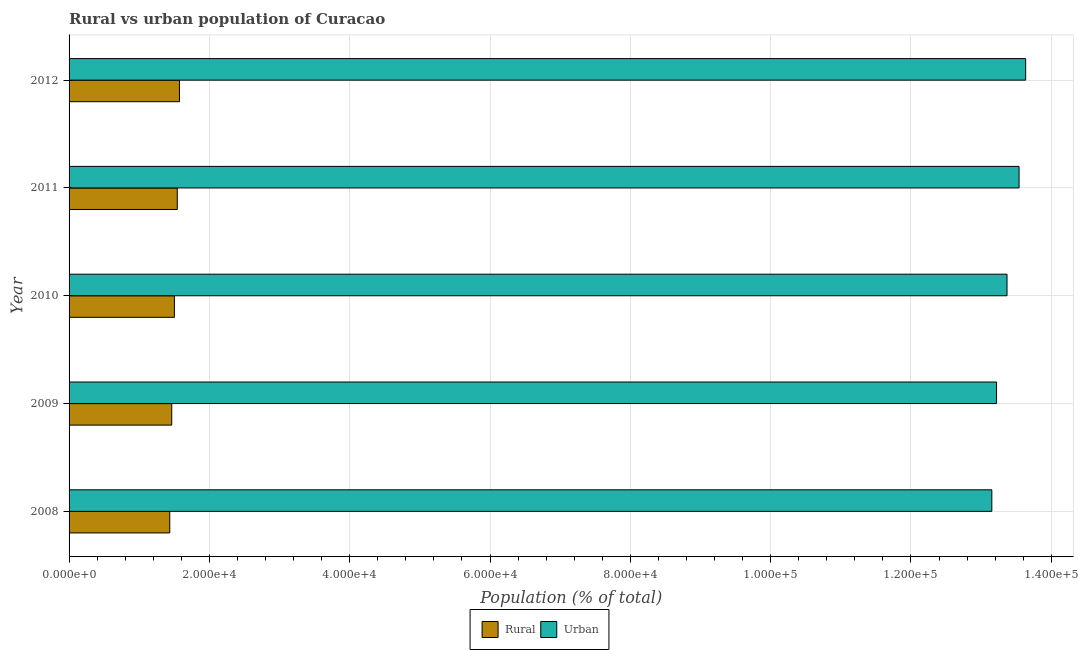How many different coloured bars are there?
Offer a terse response. 2. How many groups of bars are there?
Make the answer very short. 5. Are the number of bars per tick equal to the number of legend labels?
Provide a short and direct response. Yes. How many bars are there on the 3rd tick from the bottom?
Your response must be concise. 2. What is the label of the 5th group of bars from the top?
Provide a succinct answer. 2008. What is the urban population density in 2011?
Provide a succinct answer. 1.35e+05. Across all years, what is the maximum urban population density?
Keep it short and to the point. 1.36e+05. Across all years, what is the minimum urban population density?
Provide a short and direct response. 1.32e+05. In which year was the rural population density maximum?
Provide a short and direct response. 2012. In which year was the urban population density minimum?
Keep it short and to the point. 2008. What is the total rural population density in the graph?
Offer a terse response. 7.52e+04. What is the difference between the urban population density in 2009 and that in 2011?
Provide a short and direct response. -3209. What is the difference between the rural population density in 2008 and the urban population density in 2012?
Your answer should be compact. -1.22e+05. What is the average urban population density per year?
Your answer should be compact. 1.34e+05. In the year 2008, what is the difference between the rural population density and urban population density?
Provide a short and direct response. -1.17e+05. In how many years, is the rural population density greater than 124000 %?
Provide a succinct answer. 0. What is the ratio of the rural population density in 2009 to that in 2010?
Your answer should be compact. 0.97. Is the difference between the urban population density in 2011 and 2012 greater than the difference between the rural population density in 2011 and 2012?
Ensure brevity in your answer.  No. What is the difference between the highest and the second highest rural population density?
Provide a short and direct response. 316. What is the difference between the highest and the lowest rural population density?
Your answer should be compact. 1385. What does the 2nd bar from the top in 2008 represents?
Ensure brevity in your answer.  Rural. What does the 1st bar from the bottom in 2011 represents?
Your answer should be very brief. Rural. How many years are there in the graph?
Offer a terse response. 5. Does the graph contain any zero values?
Offer a terse response. No. Does the graph contain grids?
Offer a very short reply. Yes. How many legend labels are there?
Provide a short and direct response. 2. What is the title of the graph?
Your answer should be compact. Rural vs urban population of Curacao. What is the label or title of the X-axis?
Make the answer very short. Population (% of total). What is the label or title of the Y-axis?
Offer a very short reply. Year. What is the Population (% of total) in Rural in 2008?
Your answer should be very brief. 1.44e+04. What is the Population (% of total) of Urban in 2008?
Provide a succinct answer. 1.32e+05. What is the Population (% of total) in Rural in 2009?
Offer a very short reply. 1.46e+04. What is the Population (% of total) in Urban in 2009?
Ensure brevity in your answer.  1.32e+05. What is the Population (% of total) in Rural in 2010?
Offer a very short reply. 1.50e+04. What is the Population (% of total) of Urban in 2010?
Your answer should be very brief. 1.34e+05. What is the Population (% of total) in Rural in 2011?
Make the answer very short. 1.54e+04. What is the Population (% of total) of Urban in 2011?
Ensure brevity in your answer.  1.35e+05. What is the Population (% of total) in Rural in 2012?
Give a very brief answer. 1.57e+04. What is the Population (% of total) in Urban in 2012?
Your response must be concise. 1.36e+05. Across all years, what is the maximum Population (% of total) of Rural?
Make the answer very short. 1.57e+04. Across all years, what is the maximum Population (% of total) in Urban?
Make the answer very short. 1.36e+05. Across all years, what is the minimum Population (% of total) of Rural?
Your answer should be very brief. 1.44e+04. Across all years, what is the minimum Population (% of total) in Urban?
Your answer should be compact. 1.32e+05. What is the total Population (% of total) in Rural in the graph?
Offer a terse response. 7.52e+04. What is the total Population (% of total) of Urban in the graph?
Provide a succinct answer. 6.69e+05. What is the difference between the Population (% of total) of Rural in 2008 and that in 2009?
Your answer should be compact. -280. What is the difference between the Population (% of total) of Urban in 2008 and that in 2009?
Keep it short and to the point. -673. What is the difference between the Population (% of total) in Rural in 2008 and that in 2010?
Your response must be concise. -659. What is the difference between the Population (% of total) of Urban in 2008 and that in 2010?
Provide a short and direct response. -2164. What is the difference between the Population (% of total) in Rural in 2008 and that in 2011?
Your response must be concise. -1069. What is the difference between the Population (% of total) of Urban in 2008 and that in 2011?
Give a very brief answer. -3882. What is the difference between the Population (% of total) of Rural in 2008 and that in 2012?
Ensure brevity in your answer.  -1385. What is the difference between the Population (% of total) in Urban in 2008 and that in 2012?
Your answer should be very brief. -4823. What is the difference between the Population (% of total) in Rural in 2009 and that in 2010?
Make the answer very short. -379. What is the difference between the Population (% of total) of Urban in 2009 and that in 2010?
Give a very brief answer. -1491. What is the difference between the Population (% of total) of Rural in 2009 and that in 2011?
Ensure brevity in your answer.  -789. What is the difference between the Population (% of total) of Urban in 2009 and that in 2011?
Make the answer very short. -3209. What is the difference between the Population (% of total) of Rural in 2009 and that in 2012?
Your response must be concise. -1105. What is the difference between the Population (% of total) in Urban in 2009 and that in 2012?
Offer a very short reply. -4150. What is the difference between the Population (% of total) of Rural in 2010 and that in 2011?
Keep it short and to the point. -410. What is the difference between the Population (% of total) of Urban in 2010 and that in 2011?
Provide a succinct answer. -1718. What is the difference between the Population (% of total) in Rural in 2010 and that in 2012?
Provide a short and direct response. -726. What is the difference between the Population (% of total) of Urban in 2010 and that in 2012?
Ensure brevity in your answer.  -2659. What is the difference between the Population (% of total) of Rural in 2011 and that in 2012?
Give a very brief answer. -316. What is the difference between the Population (% of total) in Urban in 2011 and that in 2012?
Provide a short and direct response. -941. What is the difference between the Population (% of total) in Rural in 2008 and the Population (% of total) in Urban in 2009?
Your response must be concise. -1.18e+05. What is the difference between the Population (% of total) of Rural in 2008 and the Population (% of total) of Urban in 2010?
Offer a very short reply. -1.19e+05. What is the difference between the Population (% of total) of Rural in 2008 and the Population (% of total) of Urban in 2011?
Provide a short and direct response. -1.21e+05. What is the difference between the Population (% of total) of Rural in 2008 and the Population (% of total) of Urban in 2012?
Keep it short and to the point. -1.22e+05. What is the difference between the Population (% of total) in Rural in 2009 and the Population (% of total) in Urban in 2010?
Your answer should be compact. -1.19e+05. What is the difference between the Population (% of total) of Rural in 2009 and the Population (% of total) of Urban in 2011?
Offer a terse response. -1.21e+05. What is the difference between the Population (% of total) in Rural in 2009 and the Population (% of total) in Urban in 2012?
Your answer should be compact. -1.22e+05. What is the difference between the Population (% of total) in Rural in 2010 and the Population (% of total) in Urban in 2011?
Give a very brief answer. -1.20e+05. What is the difference between the Population (% of total) of Rural in 2010 and the Population (% of total) of Urban in 2012?
Your response must be concise. -1.21e+05. What is the difference between the Population (% of total) of Rural in 2011 and the Population (% of total) of Urban in 2012?
Your answer should be very brief. -1.21e+05. What is the average Population (% of total) in Rural per year?
Make the answer very short. 1.50e+04. What is the average Population (% of total) of Urban per year?
Provide a short and direct response. 1.34e+05. In the year 2008, what is the difference between the Population (% of total) of Rural and Population (% of total) of Urban?
Your response must be concise. -1.17e+05. In the year 2009, what is the difference between the Population (% of total) in Rural and Population (% of total) in Urban?
Provide a succinct answer. -1.18e+05. In the year 2010, what is the difference between the Population (% of total) in Rural and Population (% of total) in Urban?
Ensure brevity in your answer.  -1.19e+05. In the year 2011, what is the difference between the Population (% of total) of Rural and Population (% of total) of Urban?
Keep it short and to the point. -1.20e+05. In the year 2012, what is the difference between the Population (% of total) in Rural and Population (% of total) in Urban?
Ensure brevity in your answer.  -1.21e+05. What is the ratio of the Population (% of total) of Rural in 2008 to that in 2009?
Offer a terse response. 0.98. What is the ratio of the Population (% of total) of Urban in 2008 to that in 2009?
Provide a succinct answer. 0.99. What is the ratio of the Population (% of total) of Rural in 2008 to that in 2010?
Provide a succinct answer. 0.96. What is the ratio of the Population (% of total) of Urban in 2008 to that in 2010?
Provide a succinct answer. 0.98. What is the ratio of the Population (% of total) in Rural in 2008 to that in 2011?
Give a very brief answer. 0.93. What is the ratio of the Population (% of total) of Urban in 2008 to that in 2011?
Give a very brief answer. 0.97. What is the ratio of the Population (% of total) in Rural in 2008 to that in 2012?
Make the answer very short. 0.91. What is the ratio of the Population (% of total) in Urban in 2008 to that in 2012?
Your answer should be very brief. 0.96. What is the ratio of the Population (% of total) of Rural in 2009 to that in 2010?
Provide a succinct answer. 0.97. What is the ratio of the Population (% of total) of Urban in 2009 to that in 2010?
Your answer should be compact. 0.99. What is the ratio of the Population (% of total) of Rural in 2009 to that in 2011?
Provide a short and direct response. 0.95. What is the ratio of the Population (% of total) in Urban in 2009 to that in 2011?
Your answer should be very brief. 0.98. What is the ratio of the Population (% of total) of Rural in 2009 to that in 2012?
Offer a terse response. 0.93. What is the ratio of the Population (% of total) of Urban in 2009 to that in 2012?
Your answer should be compact. 0.97. What is the ratio of the Population (% of total) in Rural in 2010 to that in 2011?
Your response must be concise. 0.97. What is the ratio of the Population (% of total) in Urban in 2010 to that in 2011?
Your answer should be very brief. 0.99. What is the ratio of the Population (% of total) in Rural in 2010 to that in 2012?
Your response must be concise. 0.95. What is the ratio of the Population (% of total) in Urban in 2010 to that in 2012?
Give a very brief answer. 0.98. What is the ratio of the Population (% of total) in Rural in 2011 to that in 2012?
Keep it short and to the point. 0.98. What is the difference between the highest and the second highest Population (% of total) in Rural?
Offer a terse response. 316. What is the difference between the highest and the second highest Population (% of total) of Urban?
Keep it short and to the point. 941. What is the difference between the highest and the lowest Population (% of total) of Rural?
Keep it short and to the point. 1385. What is the difference between the highest and the lowest Population (% of total) of Urban?
Make the answer very short. 4823. 